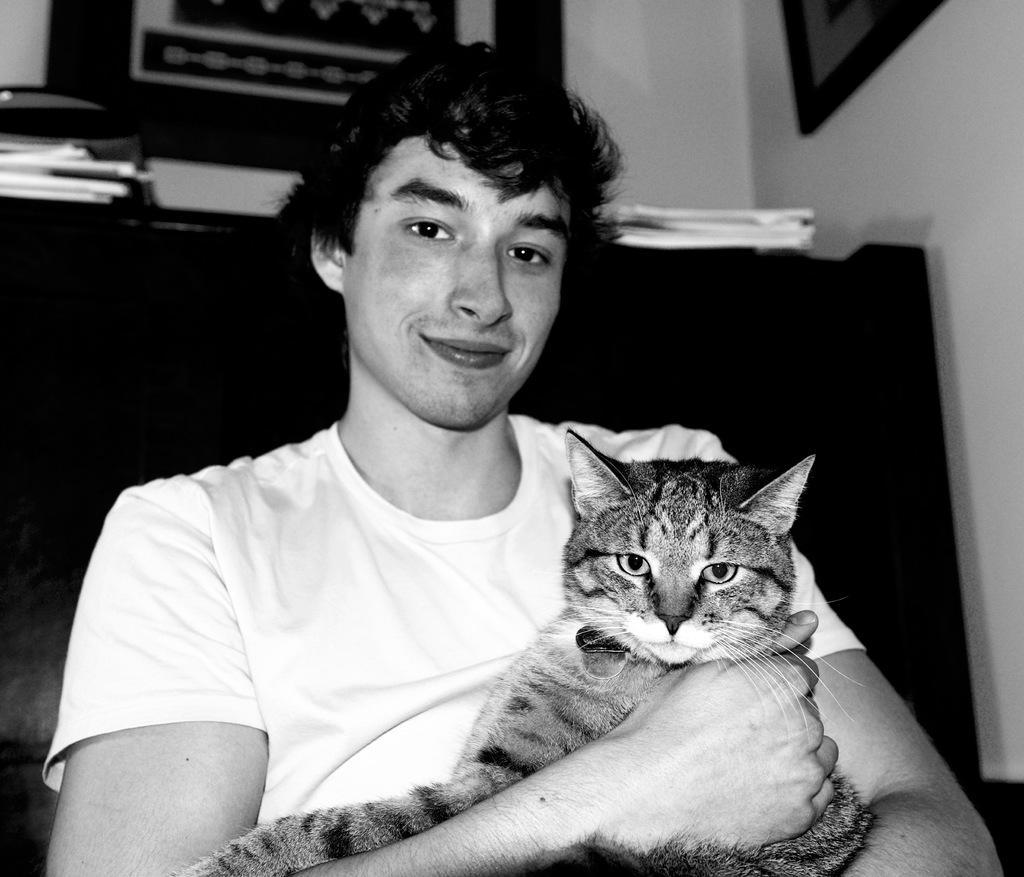How would you summarize this image in a sentence or two? Boy holding cat. 